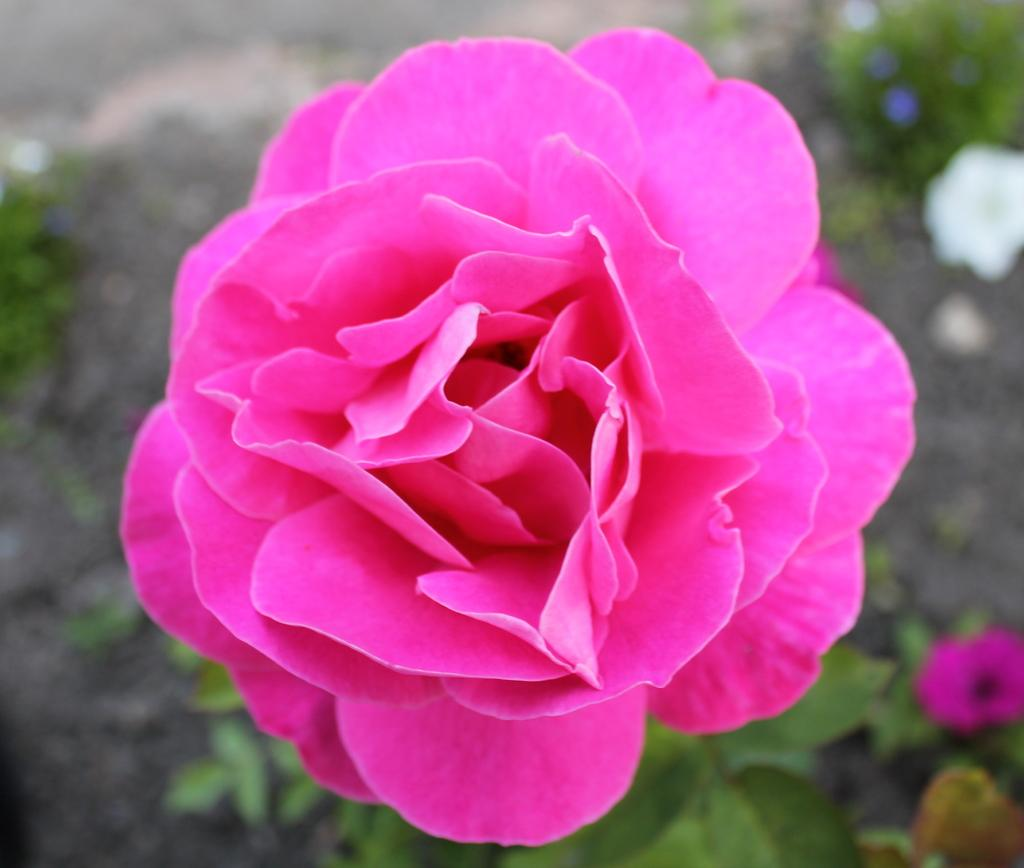What type of living organisms can be seen in the image? Flowers and plants are visible in the image. Can you describe the plants in the image? The image contains flowers, which are a type of plant. What type of celery can be seen growing among the flowers in the image? There is no celery present in the image; it only contains flowers and plants. 